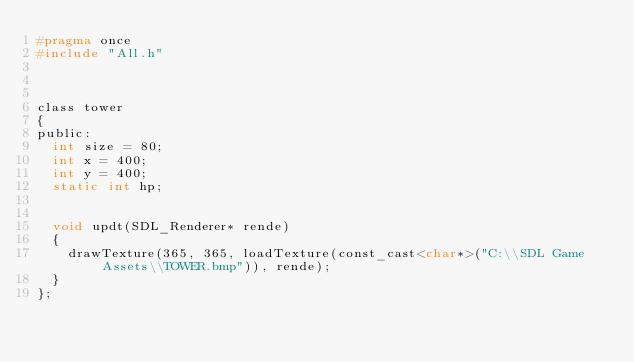<code> <loc_0><loc_0><loc_500><loc_500><_C_>#pragma once
#include "All.h"



class tower
{
public:
	int size = 80;
	int x = 400;
	int y = 400;
	static int hp;


	void updt(SDL_Renderer* rende)
	{
		drawTexture(365, 365, loadTexture(const_cast<char*>("C:\\SDL Game Assets\\TOWER.bmp")), rende);
	}
};</code> 